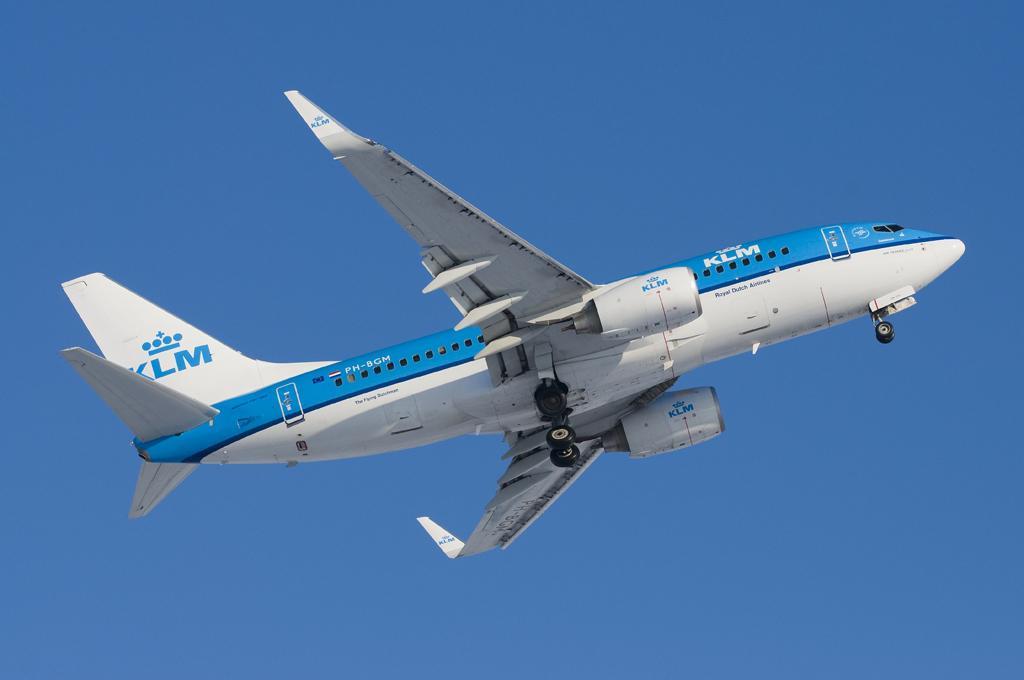Could you give a brief overview of what you see in this image? In the center of the image an aeroplane is there. In the background of the image sky is present. 